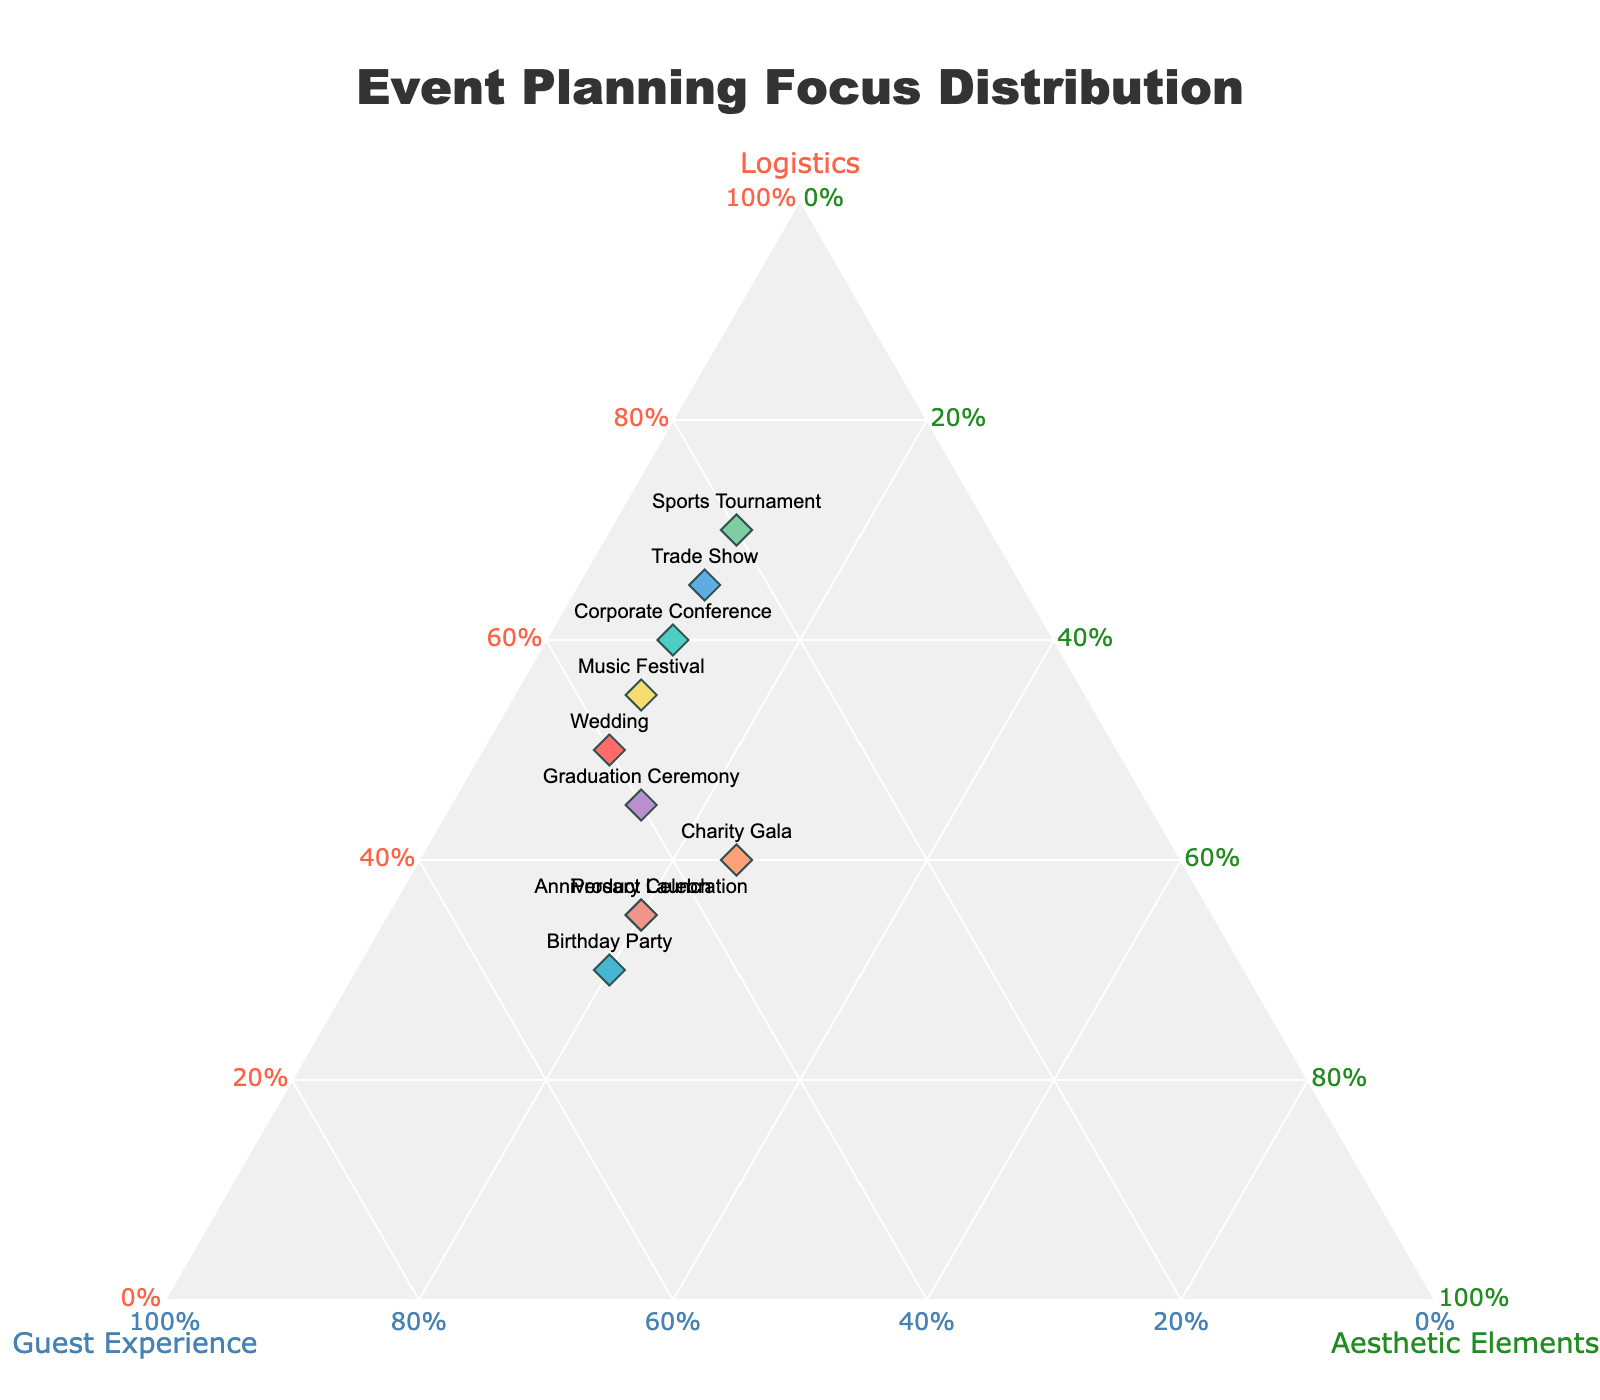How many types of events are displayed in the plot? Count the number of unique data points as each represents a different event type.
Answer: 10 What is the dominant focus for a Sports Tournament? Find the point labeled "Sports Tournament" and observe its position closest to the axis representing Logistics.
Answer: Logistics Which event type has the highest proportion of time spent on Guest Experience? Identify the point with the highest b-coordinate value, representing Guest Experience.
Answer: Birthday Party and Anniversary Celebration Between Weddings and Charity Galas, which event has a higher proportion of time spent on Aesthetic Elements? Compare the c-coordinate values of the points labeled "Wedding" and "Charity Gala".
Answer: Charity Gala What is the average proportion of time spent on Aesthetic Elements across all event types? Sum all the proportions of Aesthetic Elements and divide by the number of event types. Calculation steps: (0.10 + 0.10 + 0.20 + 0.25 + 0.20 + 0.10 + 0.15 + 0.10 + 0.20 + 0.10) / 10 = 1.50 / 10
Answer: 0.15 Which events have a balanced focus on all three aspects (Logistics, Guest Experience, and Aesthetic Elements)? Look for points that do not skew heavily towards one axis, but are more centrally located.
Answer: Charity Gala, Graduation Ceremony How does a Product Launch differ from a Trade Show in terms of prioritizing Guest Experience? Compare the b-coordinate values of the points labeled "Product Launch" and "Trade Show".
Answer: Product Launch has higher Guest Experience What is the total proportion of time spent on Logistics and Guest Experience for a Corporate Conference? Add the Logistics and Guest Experience proportions for Corporate Conference. Calculation steps: 0.60 (Logistics) + 0.30 (Guest Experience) = 0.90
Answer: 0.90 Which event type spends the least time on Guest Experience? Identify the point with the lowest b-coordinate value, representing Guest Experience.
Answer: Sports Tournament What is the combined proportion of time spent on Logistics and Aesthetic Elements for a Music Festival? Add the Logistics and Aesthetic Elements proportions for Music Festival. Calculation steps: 0.55 (Logistics) + 0.10 (Aesthetic Elements) = 0.65
Answer: 0.65 